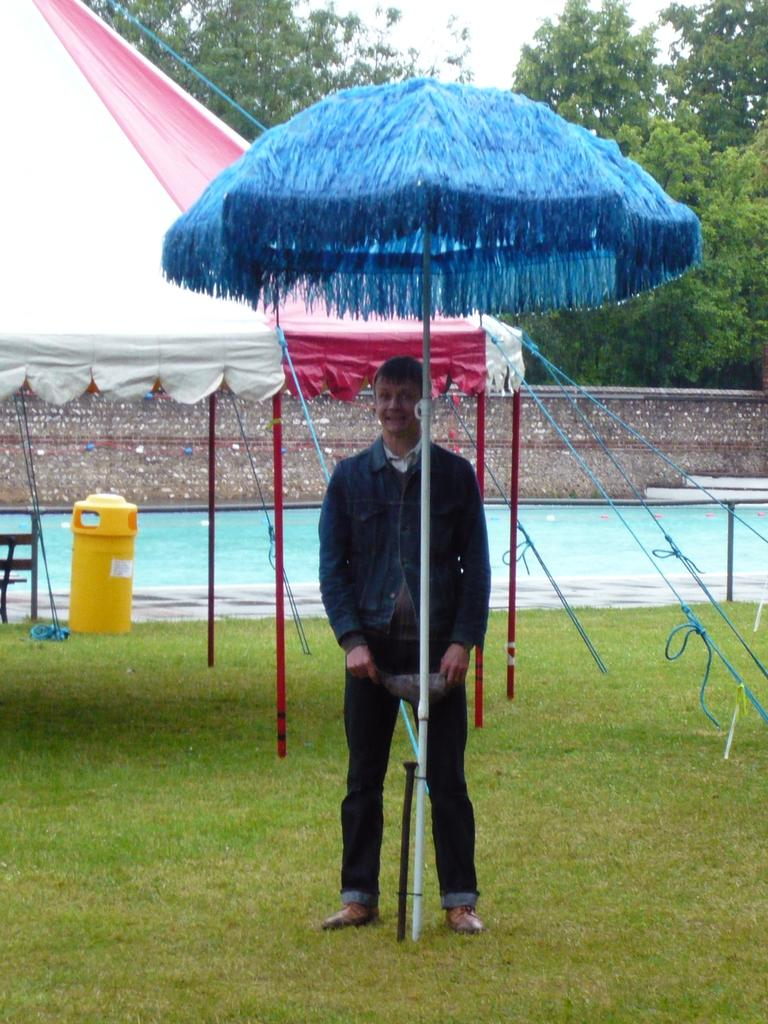What is the person in the image doing? The person is on the ground in the image. What type of temporary shelters can be seen in the image? There are tents in the image. What type of vegetation is present in the image? There is grass in the image. What type of structure is visible in the image? There is a wall in the image. What else can be seen in the image besides the person, tents, grass, and wall? There are objects in the image. What can be seen in the background of the image? There are trees and the sky visible in the background of the image. Can you see a squirrel eating an apple in the image? There is no squirrel or apple present in the image. 